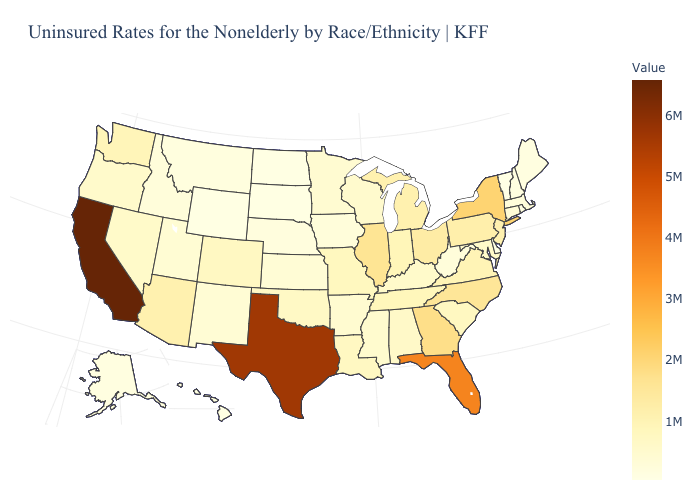Among the states that border Tennessee , does Georgia have the highest value?
Write a very short answer. Yes. Among the states that border Louisiana , which have the highest value?
Keep it brief. Texas. Which states have the lowest value in the USA?
Give a very brief answer. Vermont. Which states have the highest value in the USA?
Be succinct. California. Does Idaho have a higher value than Indiana?
Give a very brief answer. No. 